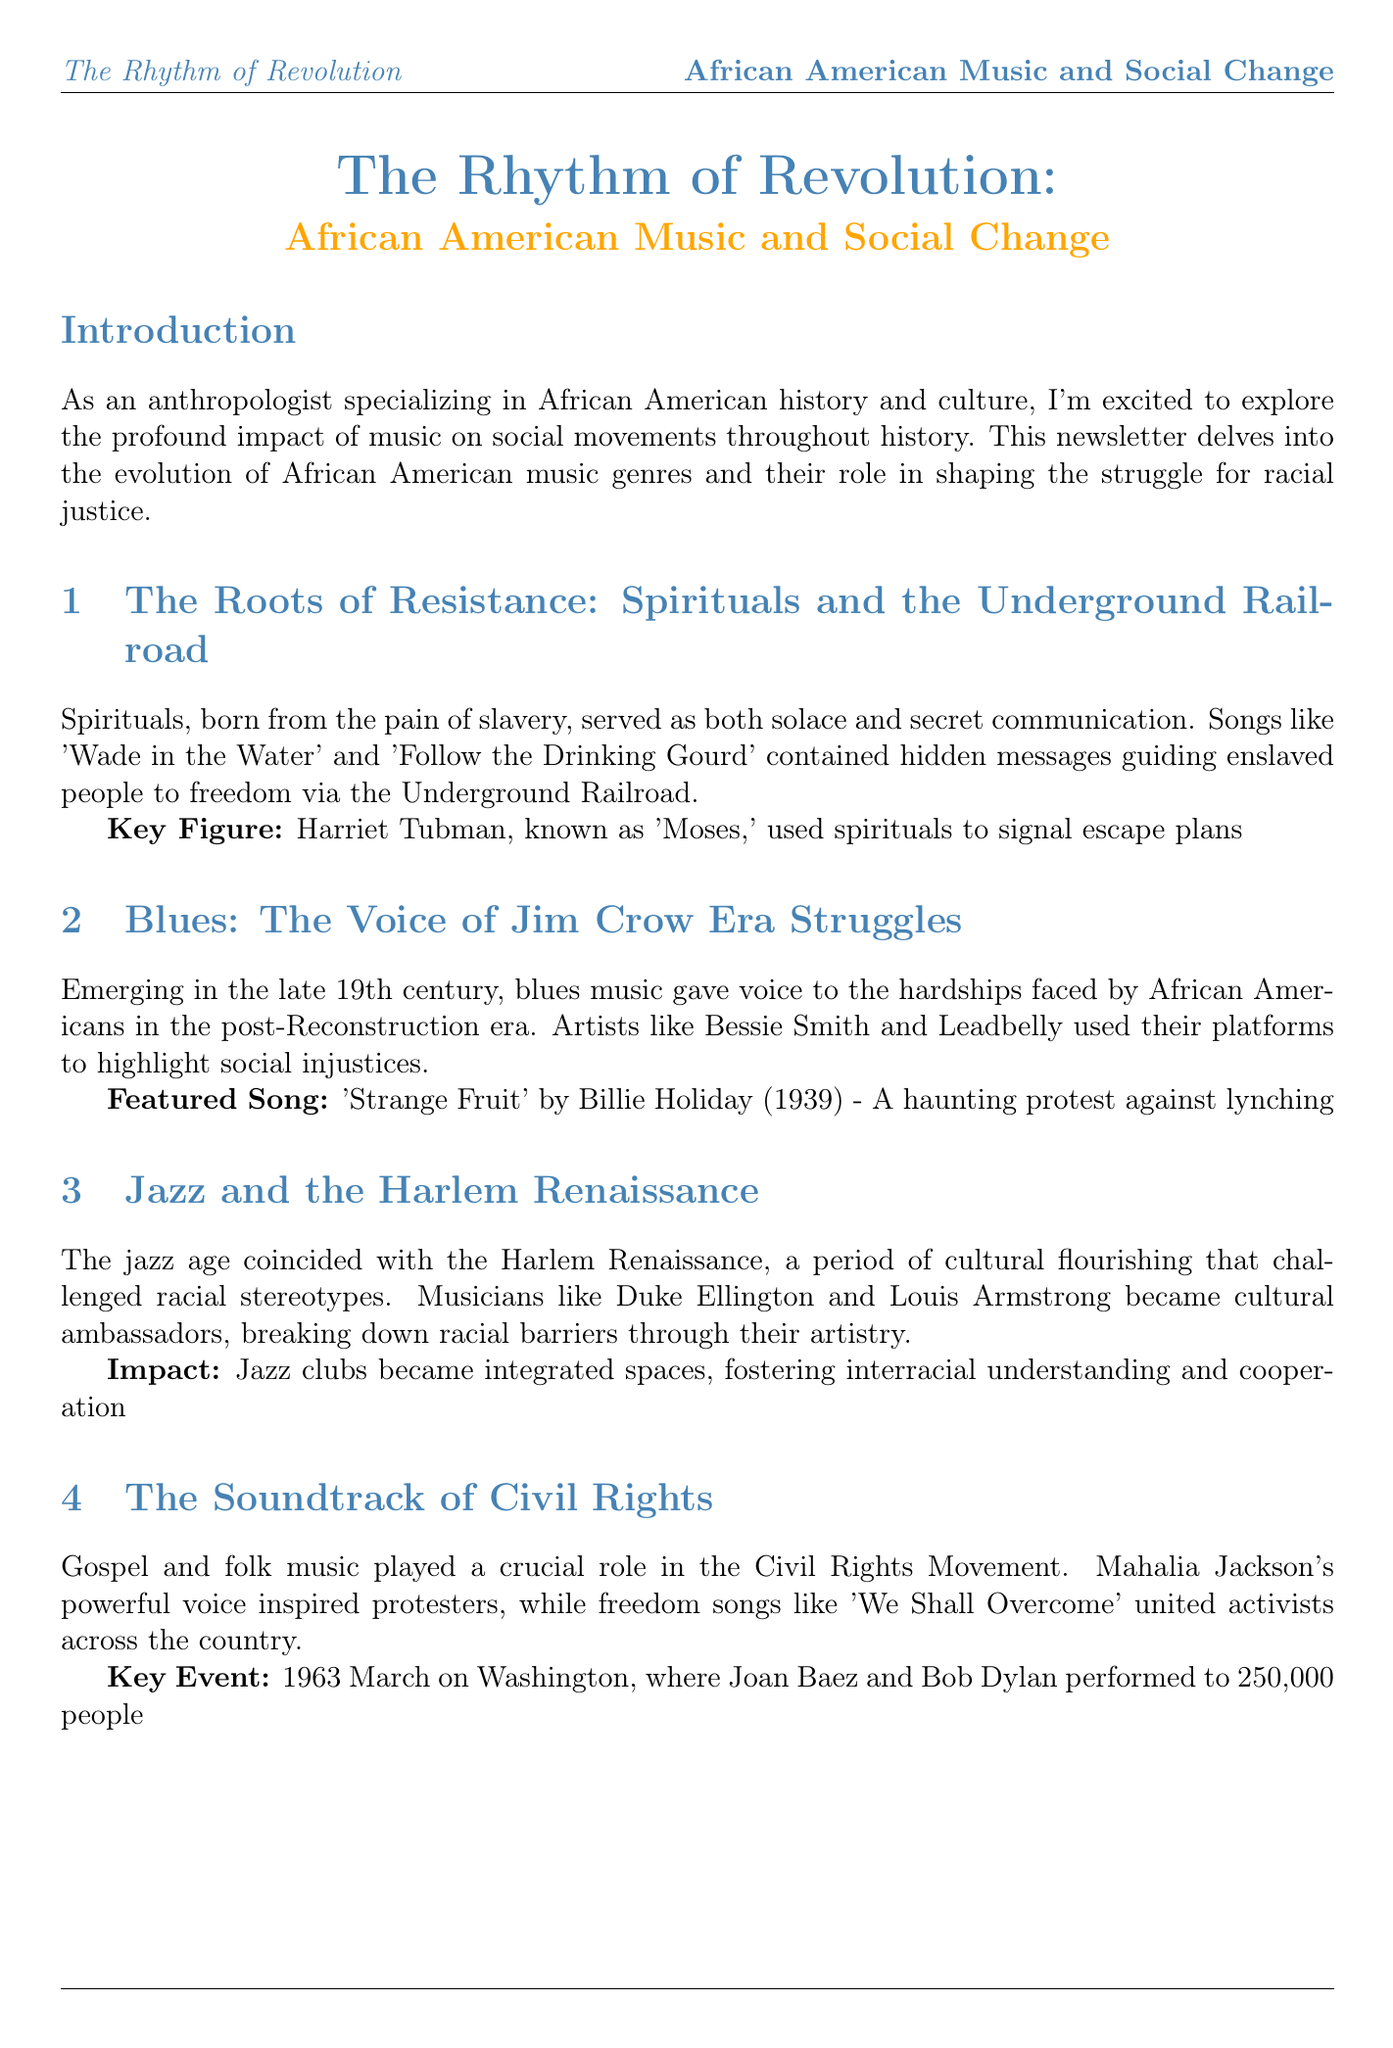what is the title of the newsletter? The title is mentioned prominently at the beginning of the document.
Answer: The Rhythm of Revolution: African American Music and Social Change who was known as 'Moses'? The document identifies Harriet Tubman's nickname in the context of spirituals.
Answer: Harriet Tubman which song did Billie Holiday record in 1939? The specific year is provided alongside the song title as a highlight in the blues section.
Answer: Strange Fruit what year did hip-hop emerge? The emergence year is noted in the hip-hop section related to the genre's history.
Answer: 1970s what genre is associated with James Brown's 'Say It Loud – I'm Black and I'm Proud'? This is mentioned in the section discussing Black Power and soul music.
Answer: Soul Music how many people attended the 1963 March on Washington? The document provides this information when discussing key events of the Civil Rights Movement.
Answer: 250,000 which musical genre had a social impact rating of 100? The bubble chart indicates the ratings for each genre based on social impact.
Answer: Hip-Hop what is the primary purpose of spirituals according to the document? The document explains the role of spirituals in the context of slavery and escape.
Answer: Secret communication what year saw the release of 'The Message' by Grandmaster Flash? The timeline provides the release year for this significant hip-hop track.
Answer: 1982 